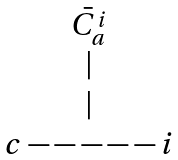Convert formula to latex. <formula><loc_0><loc_0><loc_500><loc_500>\begin{matrix} \bar { C _ { a } ^ { i } } \\ | \\ | \\ c - - - - - i \end{matrix}</formula> 